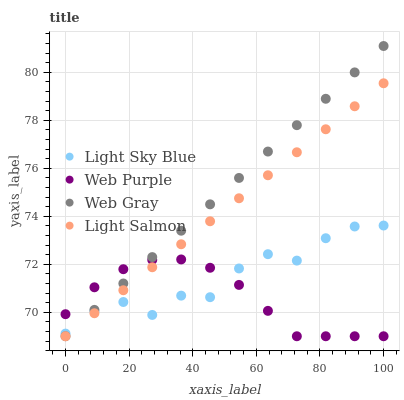Does Web Purple have the minimum area under the curve?
Answer yes or no. Yes. Does Web Gray have the maximum area under the curve?
Answer yes or no. Yes. Does Light Sky Blue have the minimum area under the curve?
Answer yes or no. No. Does Light Sky Blue have the maximum area under the curve?
Answer yes or no. No. Is Web Gray the smoothest?
Answer yes or no. Yes. Is Light Sky Blue the roughest?
Answer yes or no. Yes. Is Light Sky Blue the smoothest?
Answer yes or no. No. Is Web Gray the roughest?
Answer yes or no. No. Does Web Purple have the lowest value?
Answer yes or no. Yes. Does Light Sky Blue have the lowest value?
Answer yes or no. No. Does Web Gray have the highest value?
Answer yes or no. Yes. Does Light Sky Blue have the highest value?
Answer yes or no. No. Does Light Salmon intersect Light Sky Blue?
Answer yes or no. Yes. Is Light Salmon less than Light Sky Blue?
Answer yes or no. No. Is Light Salmon greater than Light Sky Blue?
Answer yes or no. No. 